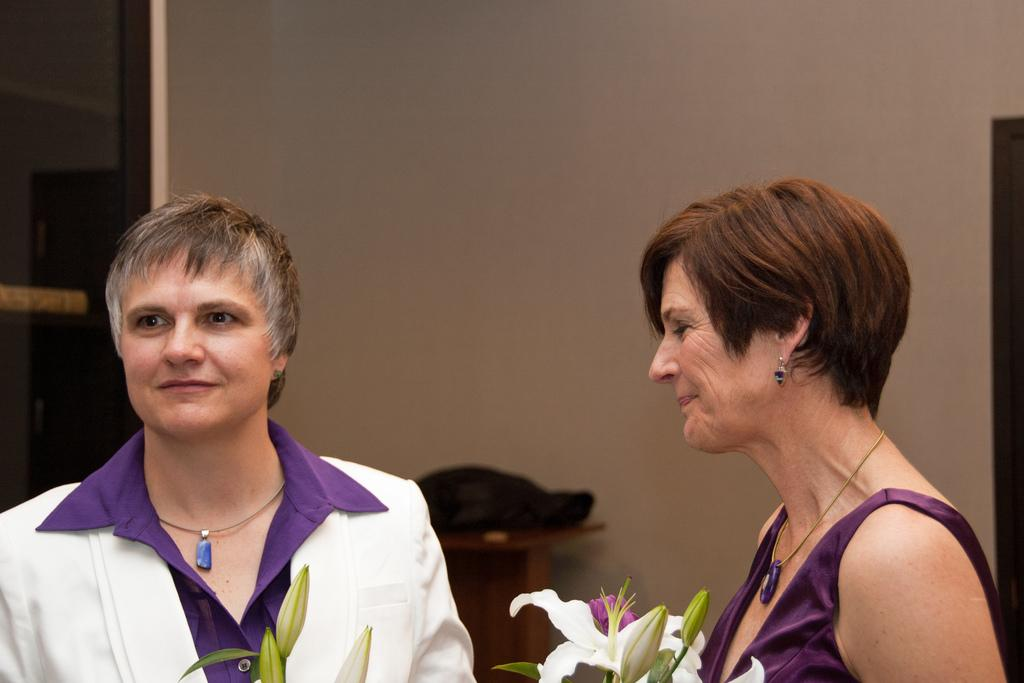How many people are in the image? There are two persons in the image. Can you describe the expression of one of the persons? One of the persons is smiling. What type of flora can be seen in the image? There are flowers in the image. What is visible in the background of the image? There is a wall and an unspecified object in the background of the image. What color is the ink used to write on the pencil in the image? There is no pencil or ink present in the image. How many balloons are visible in the image? There are no balloons present in the image. 